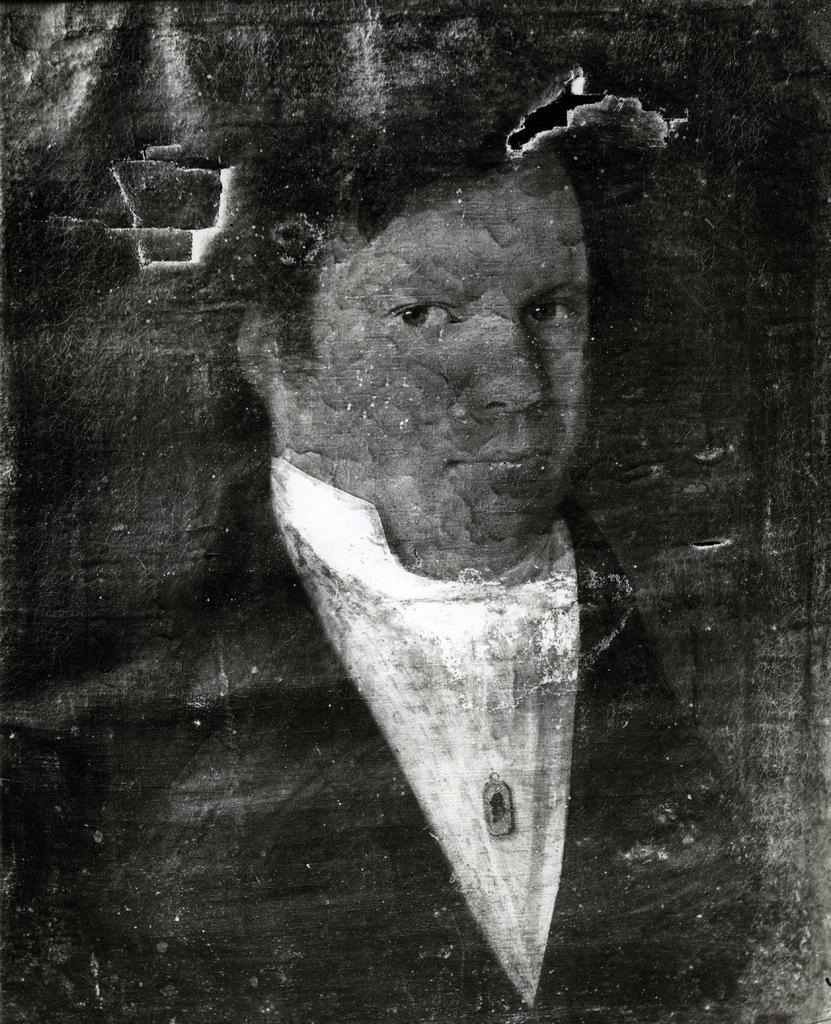Could you give a brief overview of what you see in this image? In this image I can see a person's wall painting on a wall. This image is taken may be during night. 